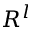<formula> <loc_0><loc_0><loc_500><loc_500>R ^ { l }</formula> 